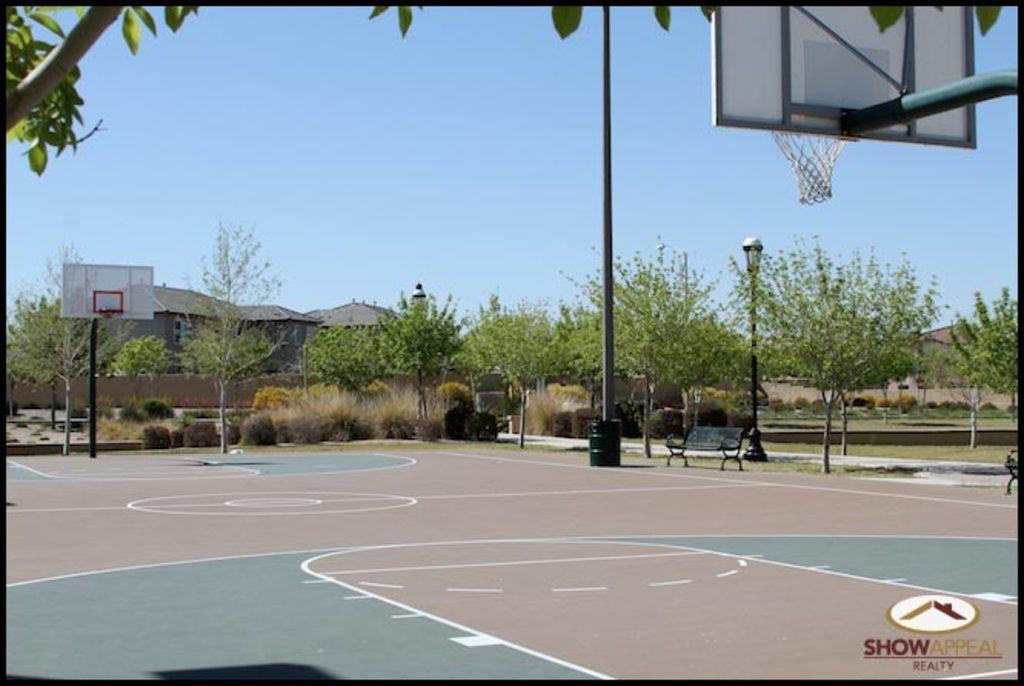Please provide a concise description of this image. In this image there is a basketball court in the bottom of this image and there are some trees in the background. There is a house on the left side of this image. There is a basketball net on the left side of this image and on the right side of this image as well. There is a sky on the top of this image. 